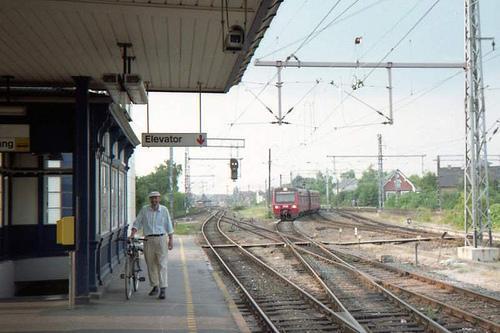How many people are pictured?
Give a very brief answer. 1. 